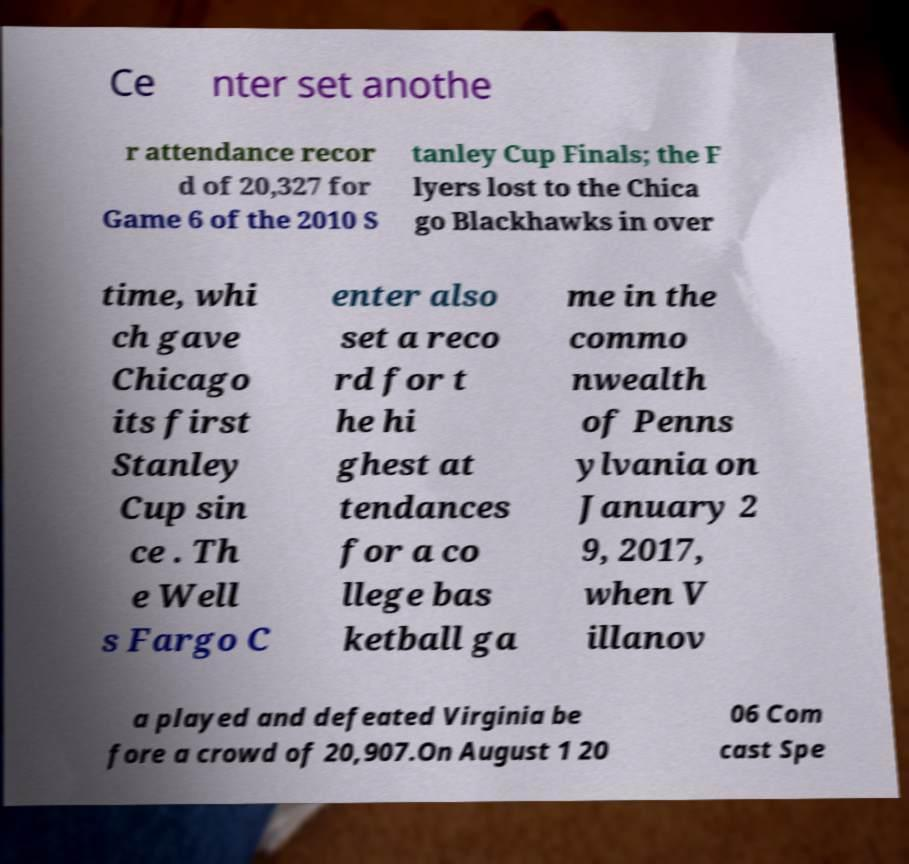For documentation purposes, I need the text within this image transcribed. Could you provide that? Ce nter set anothe r attendance recor d of 20,327 for Game 6 of the 2010 S tanley Cup Finals; the F lyers lost to the Chica go Blackhawks in over time, whi ch gave Chicago its first Stanley Cup sin ce . Th e Well s Fargo C enter also set a reco rd for t he hi ghest at tendances for a co llege bas ketball ga me in the commo nwealth of Penns ylvania on January 2 9, 2017, when V illanov a played and defeated Virginia be fore a crowd of 20,907.On August 1 20 06 Com cast Spe 